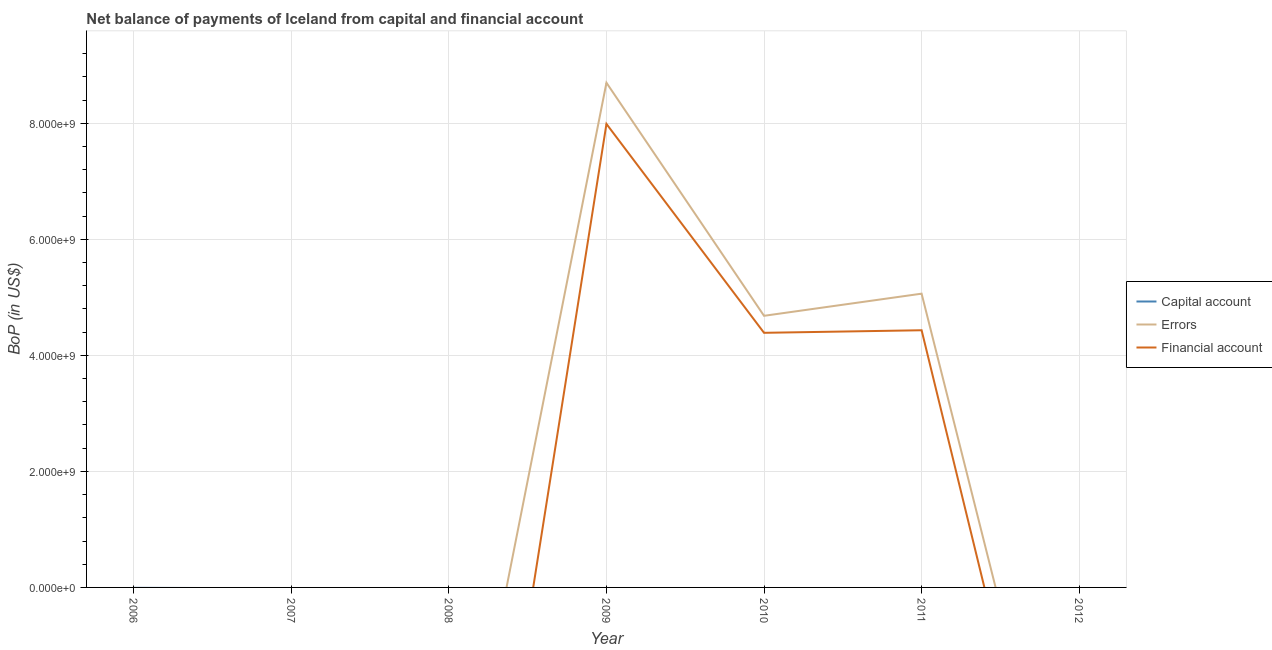How many different coloured lines are there?
Keep it short and to the point. 2. Does the line corresponding to amount of financial account intersect with the line corresponding to amount of net capital account?
Provide a short and direct response. Yes. What is the amount of net capital account in 2010?
Your response must be concise. 0. Across all years, what is the maximum amount of errors?
Make the answer very short. 8.70e+09. In which year was the amount of errors maximum?
Give a very brief answer. 2009. What is the total amount of financial account in the graph?
Ensure brevity in your answer.  1.68e+1. What is the difference between the amount of errors in 2009 and that in 2011?
Make the answer very short. 3.64e+09. In the year 2011, what is the difference between the amount of errors and amount of financial account?
Make the answer very short. 6.31e+08. What is the difference between the highest and the second highest amount of errors?
Provide a short and direct response. 3.64e+09. What is the difference between the highest and the lowest amount of financial account?
Keep it short and to the point. 7.99e+09. Does the amount of net capital account monotonically increase over the years?
Your answer should be compact. No. Is the amount of net capital account strictly less than the amount of financial account over the years?
Your answer should be compact. No. How many lines are there?
Keep it short and to the point. 2. What is the difference between two consecutive major ticks on the Y-axis?
Provide a short and direct response. 2.00e+09. Are the values on the major ticks of Y-axis written in scientific E-notation?
Your answer should be very brief. Yes. How are the legend labels stacked?
Provide a short and direct response. Vertical. What is the title of the graph?
Your response must be concise. Net balance of payments of Iceland from capital and financial account. What is the label or title of the X-axis?
Give a very brief answer. Year. What is the label or title of the Y-axis?
Ensure brevity in your answer.  BoP (in US$). What is the BoP (in US$) in Capital account in 2006?
Provide a short and direct response. 0. What is the BoP (in US$) of Errors in 2006?
Your answer should be compact. 0. What is the BoP (in US$) of Financial account in 2006?
Provide a short and direct response. 0. What is the BoP (in US$) of Capital account in 2007?
Your response must be concise. 0. What is the BoP (in US$) in Errors in 2007?
Your answer should be compact. 0. What is the BoP (in US$) of Financial account in 2008?
Keep it short and to the point. 0. What is the BoP (in US$) of Capital account in 2009?
Offer a terse response. 0. What is the BoP (in US$) in Errors in 2009?
Provide a short and direct response. 8.70e+09. What is the BoP (in US$) in Financial account in 2009?
Provide a succinct answer. 7.99e+09. What is the BoP (in US$) of Errors in 2010?
Provide a short and direct response. 4.68e+09. What is the BoP (in US$) of Financial account in 2010?
Make the answer very short. 4.39e+09. What is the BoP (in US$) in Errors in 2011?
Give a very brief answer. 5.06e+09. What is the BoP (in US$) in Financial account in 2011?
Give a very brief answer. 4.43e+09. Across all years, what is the maximum BoP (in US$) of Errors?
Provide a short and direct response. 8.70e+09. Across all years, what is the maximum BoP (in US$) in Financial account?
Offer a terse response. 7.99e+09. Across all years, what is the minimum BoP (in US$) in Financial account?
Provide a succinct answer. 0. What is the total BoP (in US$) in Capital account in the graph?
Keep it short and to the point. 0. What is the total BoP (in US$) of Errors in the graph?
Your response must be concise. 1.84e+1. What is the total BoP (in US$) in Financial account in the graph?
Provide a short and direct response. 1.68e+1. What is the difference between the BoP (in US$) of Errors in 2009 and that in 2010?
Your response must be concise. 4.02e+09. What is the difference between the BoP (in US$) of Financial account in 2009 and that in 2010?
Keep it short and to the point. 3.60e+09. What is the difference between the BoP (in US$) in Errors in 2009 and that in 2011?
Ensure brevity in your answer.  3.64e+09. What is the difference between the BoP (in US$) of Financial account in 2009 and that in 2011?
Your answer should be very brief. 3.56e+09. What is the difference between the BoP (in US$) in Errors in 2010 and that in 2011?
Make the answer very short. -3.82e+08. What is the difference between the BoP (in US$) of Financial account in 2010 and that in 2011?
Keep it short and to the point. -4.42e+07. What is the difference between the BoP (in US$) in Errors in 2009 and the BoP (in US$) in Financial account in 2010?
Provide a short and direct response. 4.31e+09. What is the difference between the BoP (in US$) of Errors in 2009 and the BoP (in US$) of Financial account in 2011?
Provide a succinct answer. 4.27e+09. What is the difference between the BoP (in US$) of Errors in 2010 and the BoP (in US$) of Financial account in 2011?
Give a very brief answer. 2.49e+08. What is the average BoP (in US$) of Errors per year?
Make the answer very short. 2.64e+09. What is the average BoP (in US$) in Financial account per year?
Keep it short and to the point. 2.40e+09. In the year 2009, what is the difference between the BoP (in US$) in Errors and BoP (in US$) in Financial account?
Give a very brief answer. 7.10e+08. In the year 2010, what is the difference between the BoP (in US$) of Errors and BoP (in US$) of Financial account?
Ensure brevity in your answer.  2.93e+08. In the year 2011, what is the difference between the BoP (in US$) of Errors and BoP (in US$) of Financial account?
Make the answer very short. 6.31e+08. What is the ratio of the BoP (in US$) in Errors in 2009 to that in 2010?
Your response must be concise. 1.86. What is the ratio of the BoP (in US$) in Financial account in 2009 to that in 2010?
Your answer should be compact. 1.82. What is the ratio of the BoP (in US$) of Errors in 2009 to that in 2011?
Ensure brevity in your answer.  1.72. What is the ratio of the BoP (in US$) of Financial account in 2009 to that in 2011?
Provide a short and direct response. 1.8. What is the ratio of the BoP (in US$) in Errors in 2010 to that in 2011?
Your answer should be compact. 0.92. What is the ratio of the BoP (in US$) in Financial account in 2010 to that in 2011?
Your answer should be very brief. 0.99. What is the difference between the highest and the second highest BoP (in US$) in Errors?
Offer a terse response. 3.64e+09. What is the difference between the highest and the second highest BoP (in US$) in Financial account?
Ensure brevity in your answer.  3.56e+09. What is the difference between the highest and the lowest BoP (in US$) in Errors?
Keep it short and to the point. 8.70e+09. What is the difference between the highest and the lowest BoP (in US$) in Financial account?
Your answer should be compact. 7.99e+09. 